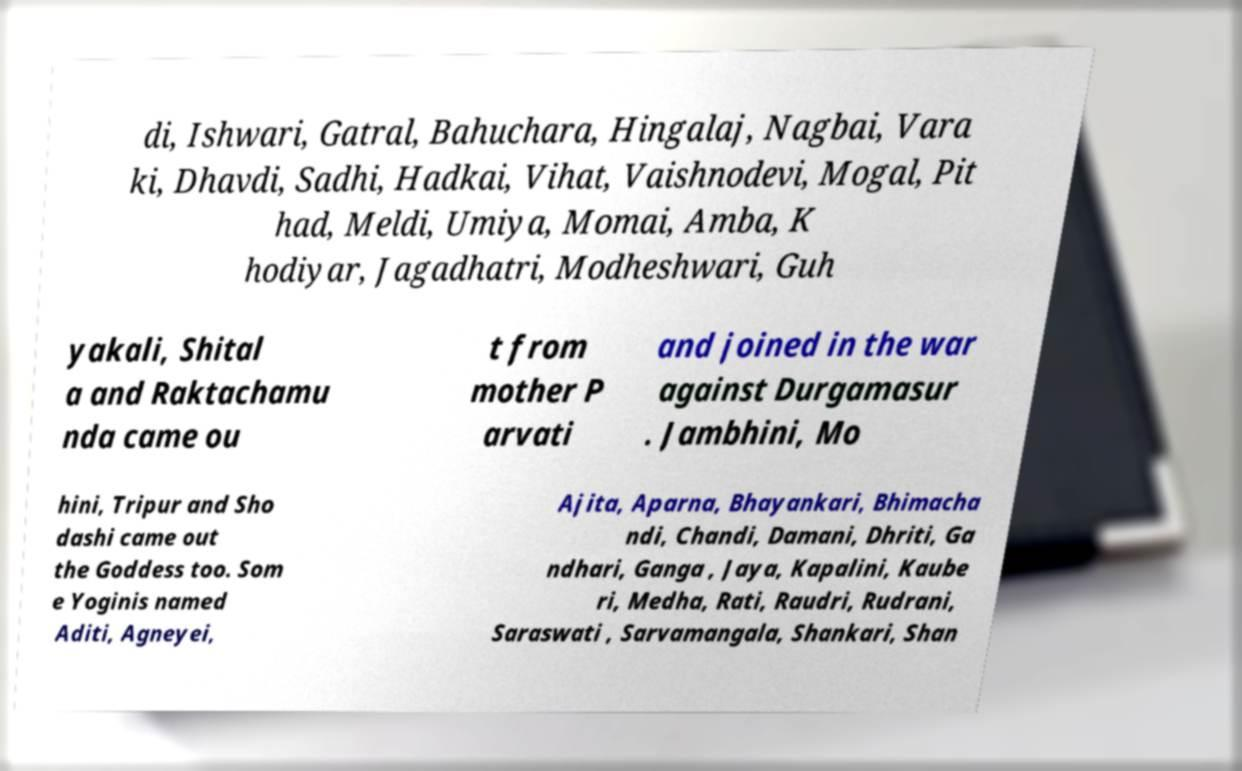Could you assist in decoding the text presented in this image and type it out clearly? di, Ishwari, Gatral, Bahuchara, Hingalaj, Nagbai, Vara ki, Dhavdi, Sadhi, Hadkai, Vihat, Vaishnodevi, Mogal, Pit had, Meldi, Umiya, Momai, Amba, K hodiyar, Jagadhatri, Modheshwari, Guh yakali, Shital a and Raktachamu nda came ou t from mother P arvati and joined in the war against Durgamasur . Jambhini, Mo hini, Tripur and Sho dashi came out the Goddess too. Som e Yoginis named Aditi, Agneyei, Ajita, Aparna, Bhayankari, Bhimacha ndi, Chandi, Damani, Dhriti, Ga ndhari, Ganga , Jaya, Kapalini, Kaube ri, Medha, Rati, Raudri, Rudrani, Saraswati , Sarvamangala, Shankari, Shan 